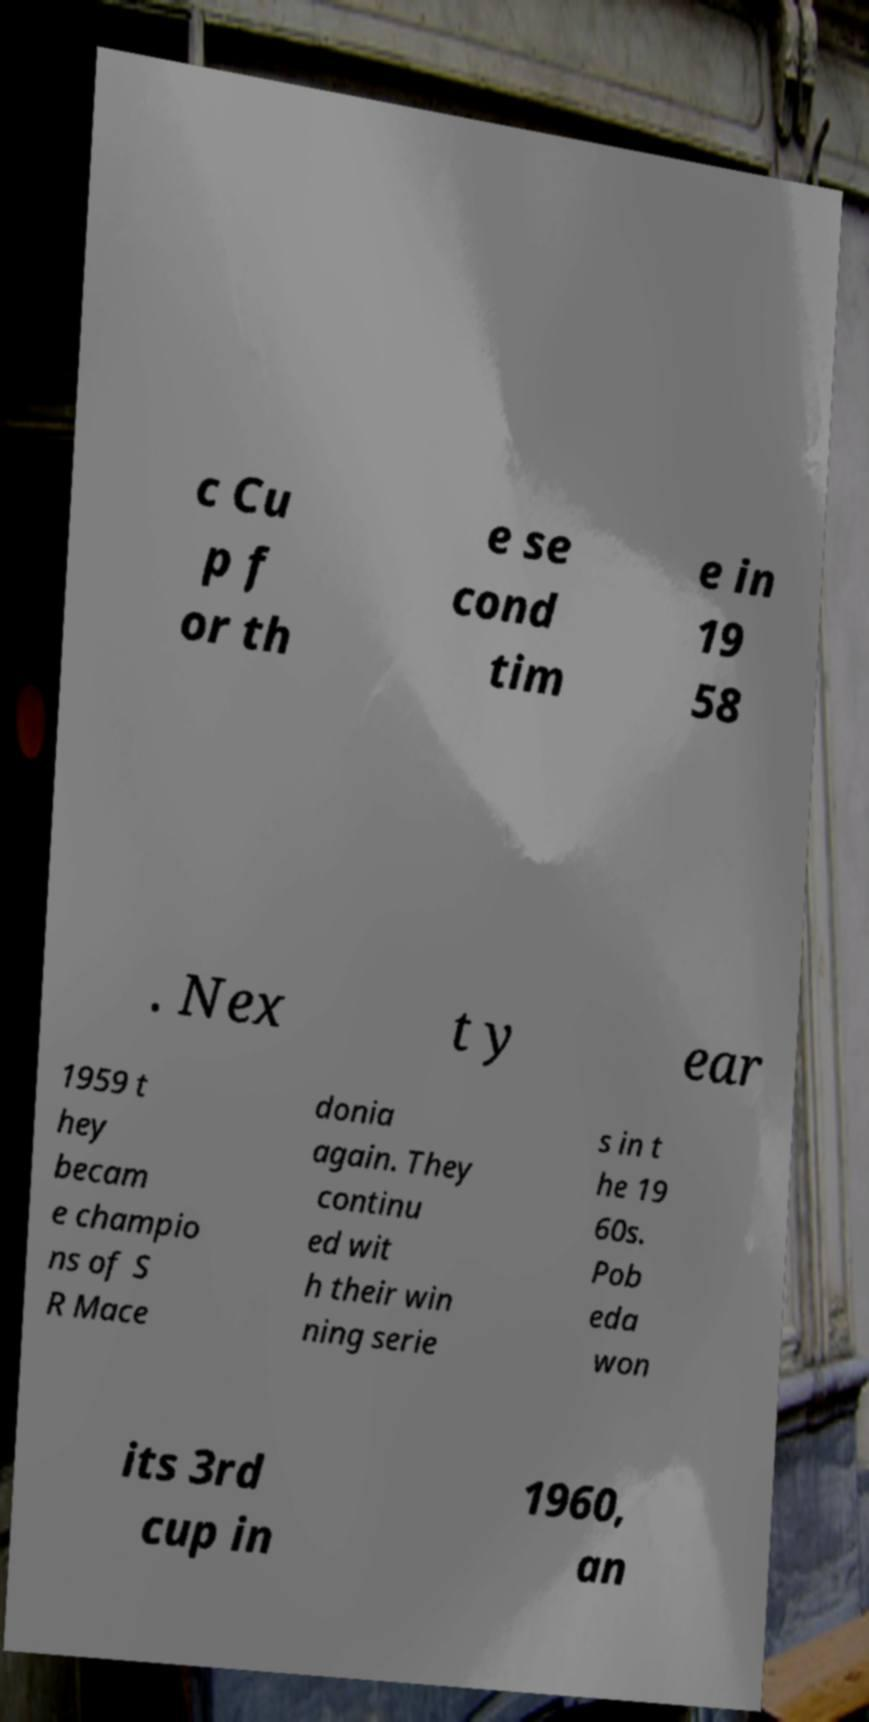Please read and relay the text visible in this image. What does it say? c Cu p f or th e se cond tim e in 19 58 . Nex t y ear 1959 t hey becam e champio ns of S R Mace donia again. They continu ed wit h their win ning serie s in t he 19 60s. Pob eda won its 3rd cup in 1960, an 